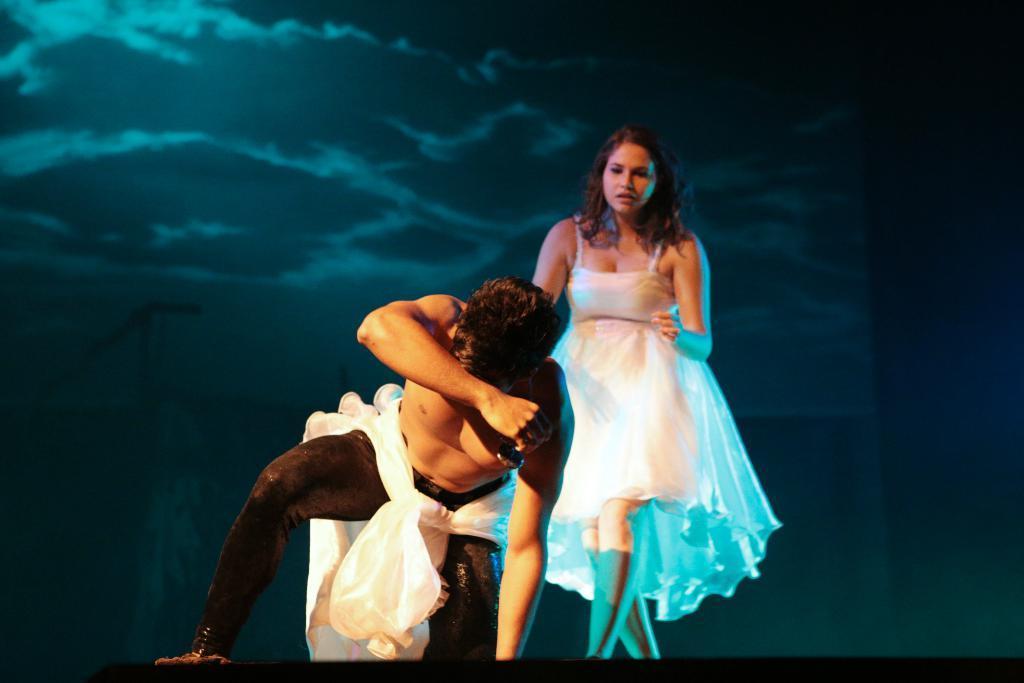Can you describe this image briefly? In this picture there is a woman who is wearing white dress. At the bottom there is a man who is wearing black trouser and shoe. Both of them were doing the drama on the stage. In the back I can see the projector screen which showing the sky and clouds. 